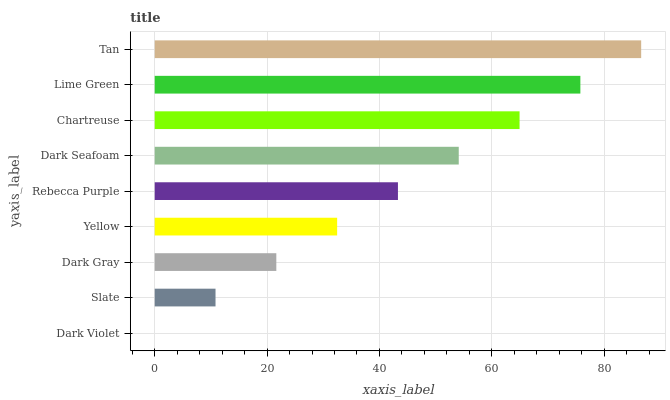Is Dark Violet the minimum?
Answer yes or no. Yes. Is Tan the maximum?
Answer yes or no. Yes. Is Slate the minimum?
Answer yes or no. No. Is Slate the maximum?
Answer yes or no. No. Is Slate greater than Dark Violet?
Answer yes or no. Yes. Is Dark Violet less than Slate?
Answer yes or no. Yes. Is Dark Violet greater than Slate?
Answer yes or no. No. Is Slate less than Dark Violet?
Answer yes or no. No. Is Rebecca Purple the high median?
Answer yes or no. Yes. Is Rebecca Purple the low median?
Answer yes or no. Yes. Is Chartreuse the high median?
Answer yes or no. No. Is Dark Violet the low median?
Answer yes or no. No. 